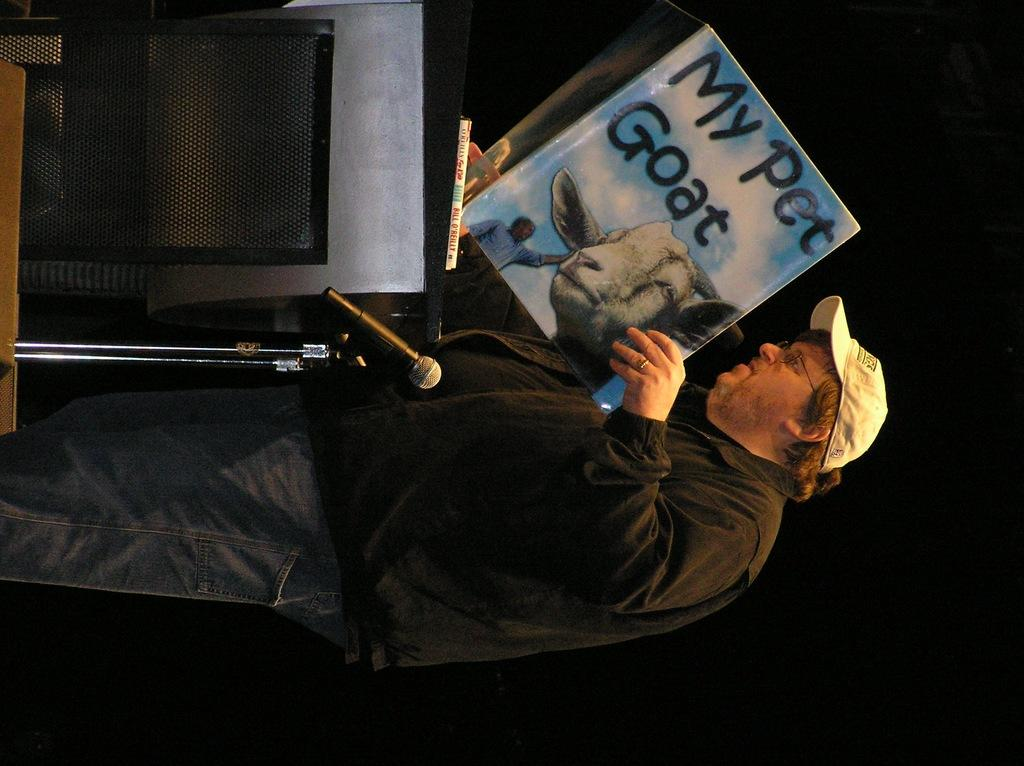<image>
Offer a succinct explanation of the picture presented. A man at a podium is holding up a My pet goat book. 